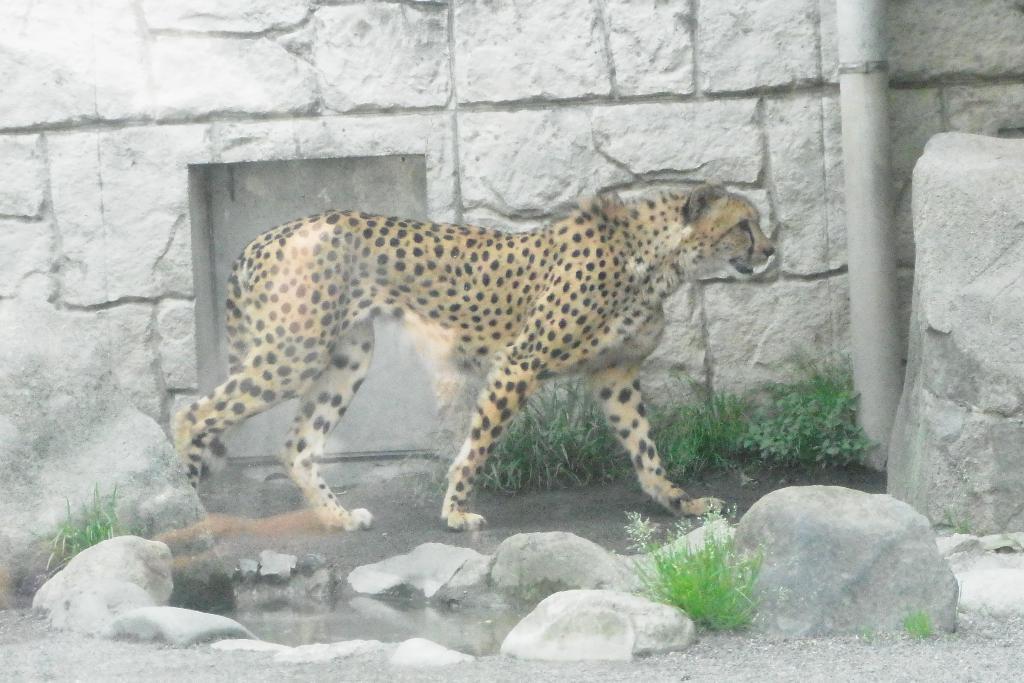Please provide a concise description of this image. In the given image i can see a wall,animal,stones and grass. 